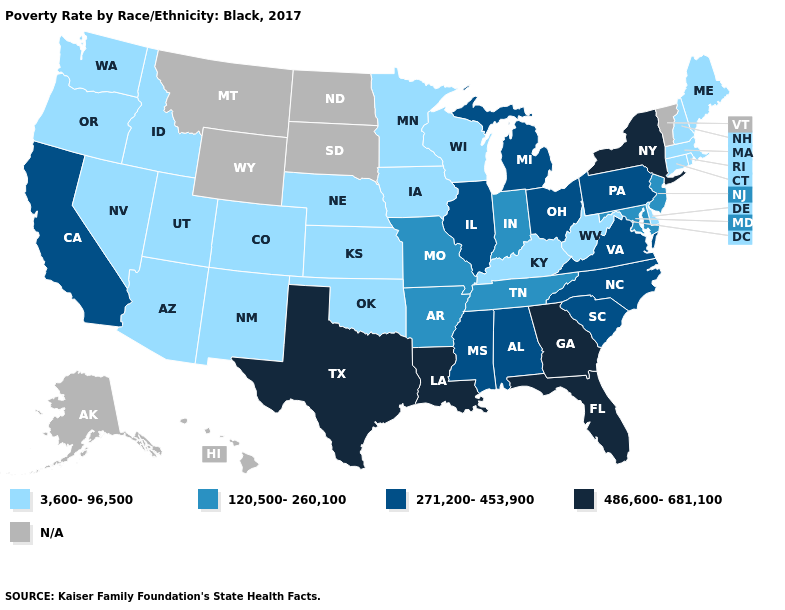Among the states that border New Mexico , does Texas have the highest value?
Give a very brief answer. Yes. What is the highest value in states that border West Virginia?
Be succinct. 271,200-453,900. Does Wisconsin have the highest value in the MidWest?
Write a very short answer. No. Which states have the lowest value in the Northeast?
Answer briefly. Connecticut, Maine, Massachusetts, New Hampshire, Rhode Island. Name the states that have a value in the range 271,200-453,900?
Be succinct. Alabama, California, Illinois, Michigan, Mississippi, North Carolina, Ohio, Pennsylvania, South Carolina, Virginia. How many symbols are there in the legend?
Short answer required. 5. How many symbols are there in the legend?
Be succinct. 5. What is the lowest value in the USA?
Write a very short answer. 3,600-96,500. Name the states that have a value in the range N/A?
Keep it brief. Alaska, Hawaii, Montana, North Dakota, South Dakota, Vermont, Wyoming. Which states have the highest value in the USA?
Answer briefly. Florida, Georgia, Louisiana, New York, Texas. Name the states that have a value in the range 120,500-260,100?
Give a very brief answer. Arkansas, Indiana, Maryland, Missouri, New Jersey, Tennessee. Does Oklahoma have the lowest value in the South?
Give a very brief answer. Yes. Name the states that have a value in the range 3,600-96,500?
Concise answer only. Arizona, Colorado, Connecticut, Delaware, Idaho, Iowa, Kansas, Kentucky, Maine, Massachusetts, Minnesota, Nebraska, Nevada, New Hampshire, New Mexico, Oklahoma, Oregon, Rhode Island, Utah, Washington, West Virginia, Wisconsin. Does Florida have the highest value in the USA?
Write a very short answer. Yes. 